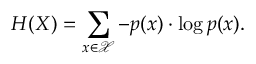Convert formula to latex. <formula><loc_0><loc_0><loc_500><loc_500>H ( X ) = \sum _ { x \in \mathcal { X } } - p ( x ) \cdot \log p ( x ) .</formula> 